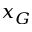<formula> <loc_0><loc_0><loc_500><loc_500>x _ { G }</formula> 